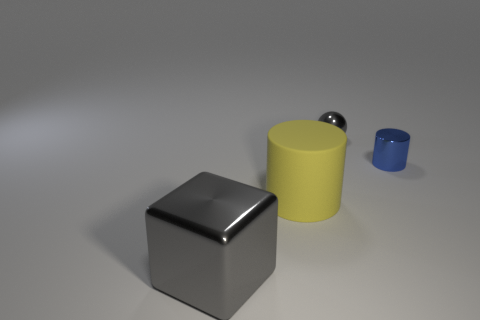Add 2 gray metallic cubes. How many objects exist? 6 Subtract all balls. How many objects are left? 3 Subtract 1 blocks. How many blocks are left? 0 Subtract all brown blocks. Subtract all cyan cylinders. How many blocks are left? 1 Subtract all blue balls. How many green blocks are left? 0 Subtract all yellow objects. Subtract all tiny gray things. How many objects are left? 2 Add 4 gray metallic spheres. How many gray metallic spheres are left? 5 Add 2 yellow rubber cylinders. How many yellow rubber cylinders exist? 3 Subtract all blue cylinders. How many cylinders are left? 1 Subtract 0 blue balls. How many objects are left? 4 